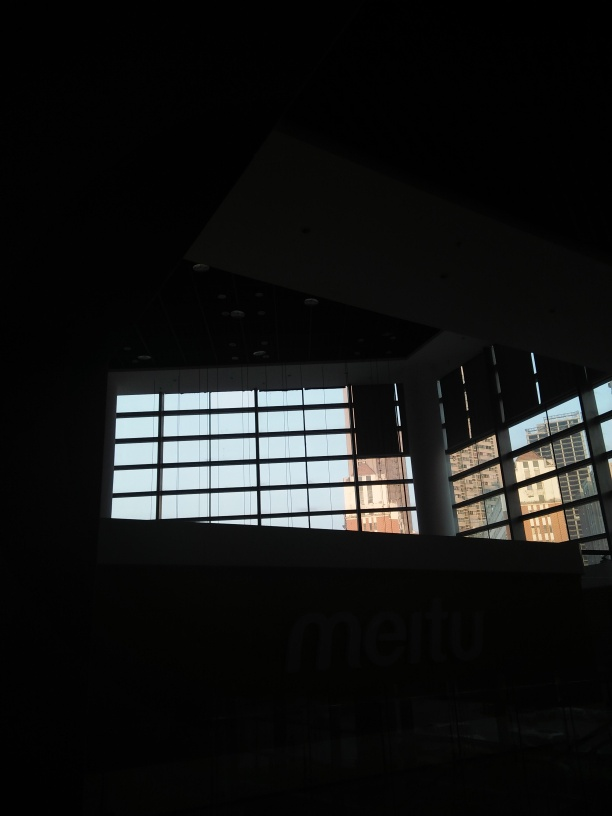Can you tell what kind of building is shown in the picture? Given the modern design with large pane windows, visible structural columns, and the word 'metu' which could imply branding, it suggests that the building is a commercial or public space, possibly a corporate office building or educational institution. Could it be a part of a university or a corporation's headquarters? That's a possibility. The design elements, such as the large windows that often aim to provide ample natural light, and the spacious layout, are consistent with those used in university buildings or corporate headquarters to create a welcoming and open environment. 